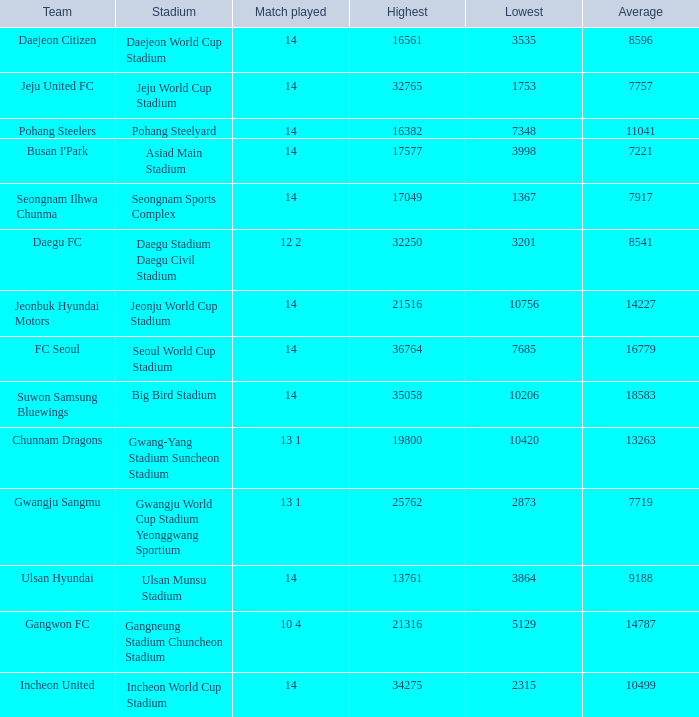What is the lowest when pohang steelyard is the stadium? 7348.0. 